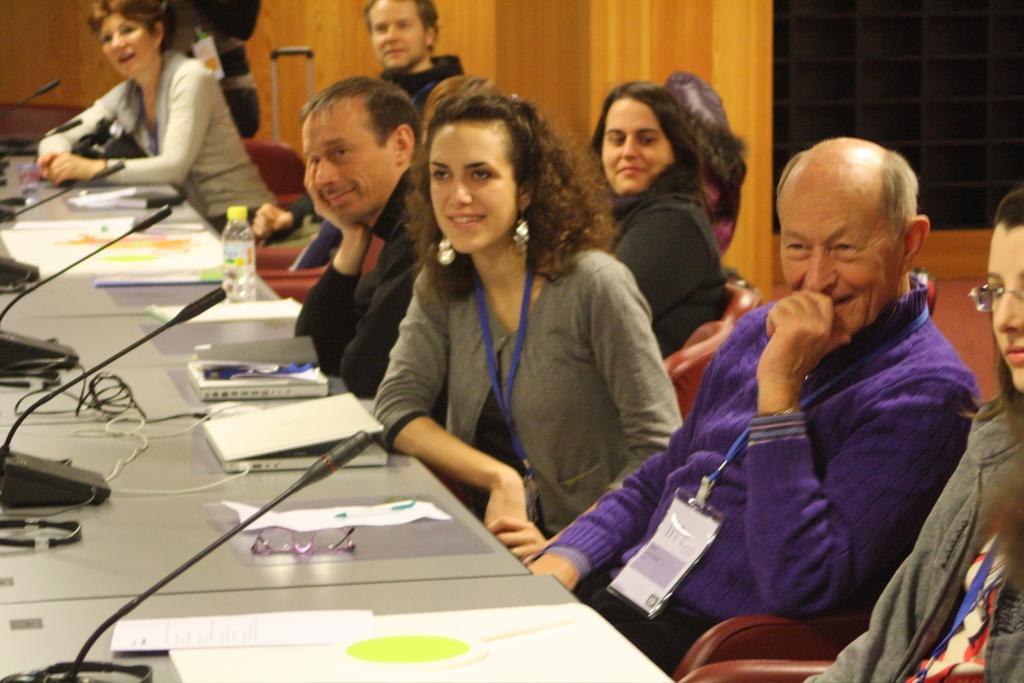Please provide a concise description of this image. There is a table and a group of people were sitting in front of a table, on the table there are papers, spectacles, mics, a bottle and few other things. In the background there is a wooden wall and there is a luggage kept in front of the wooden wall. 